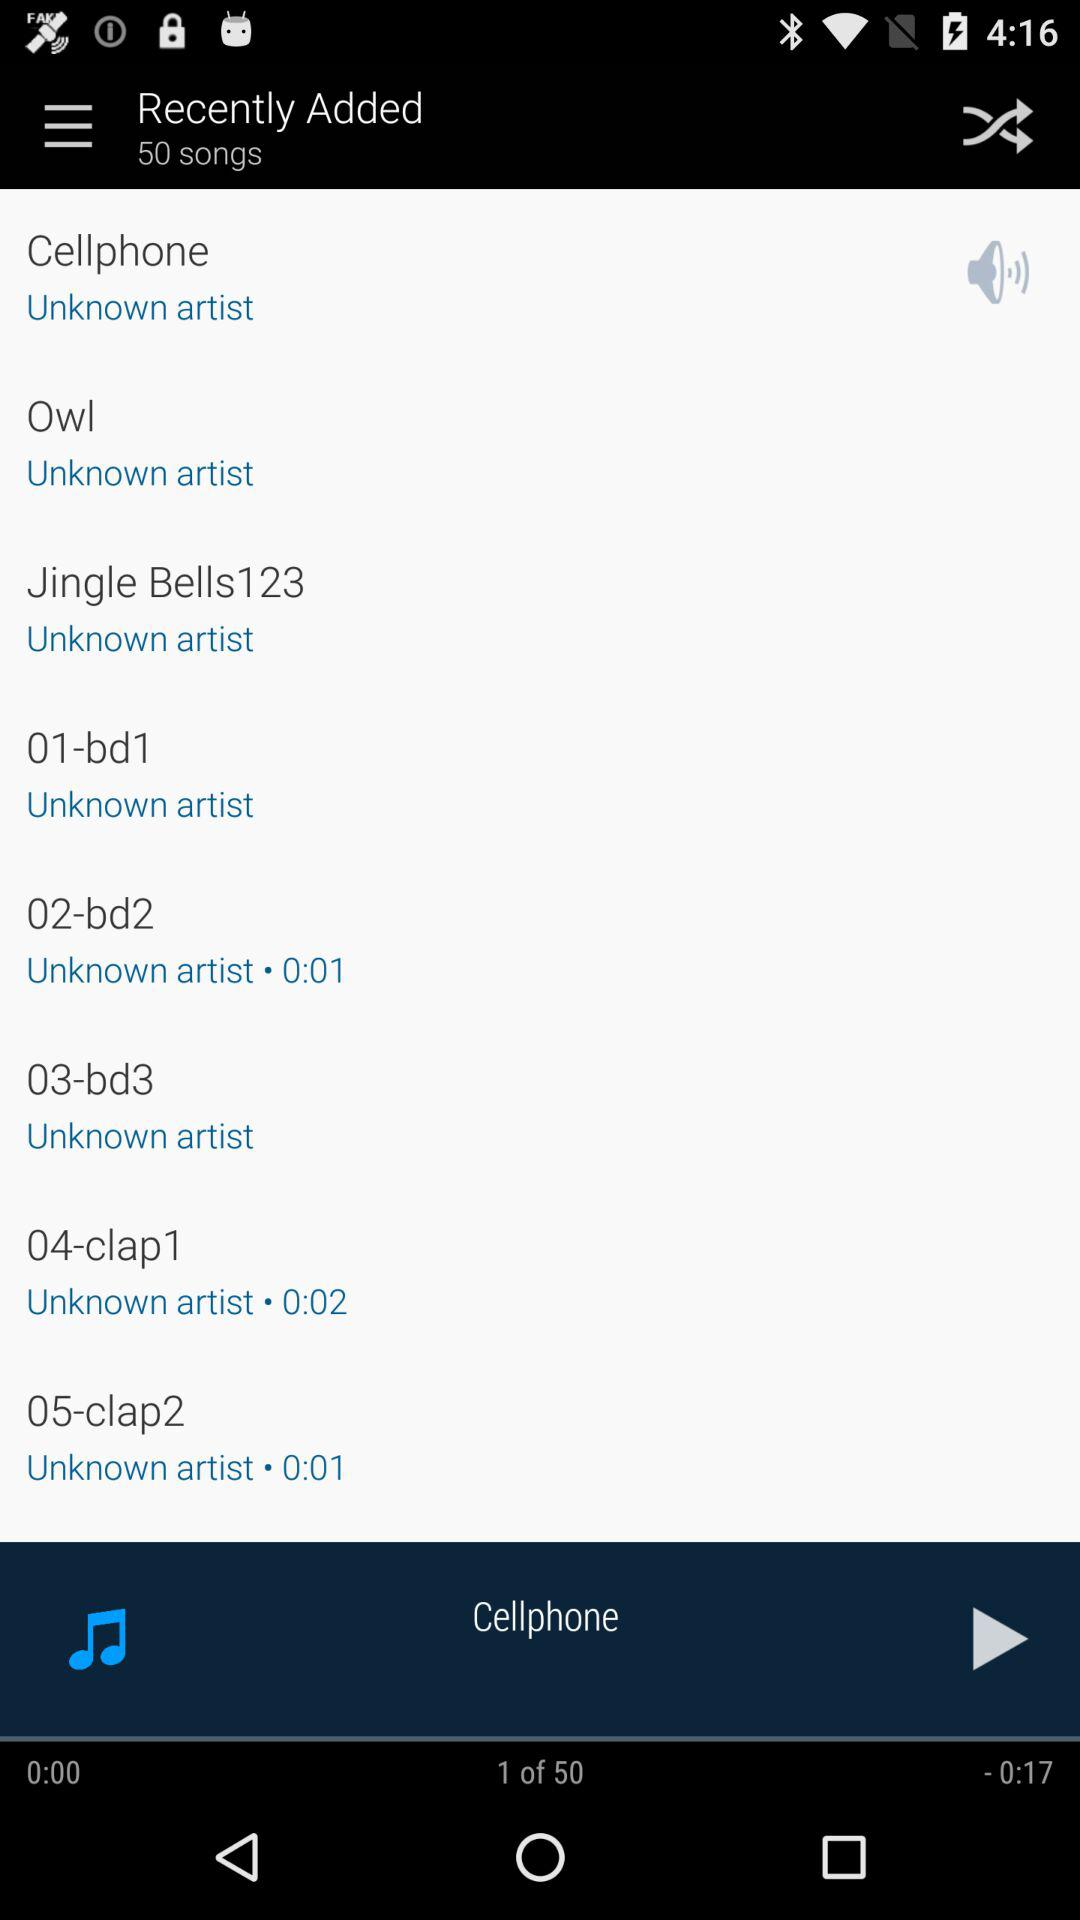How many songs were recently added? There were 50 songs added recently. 